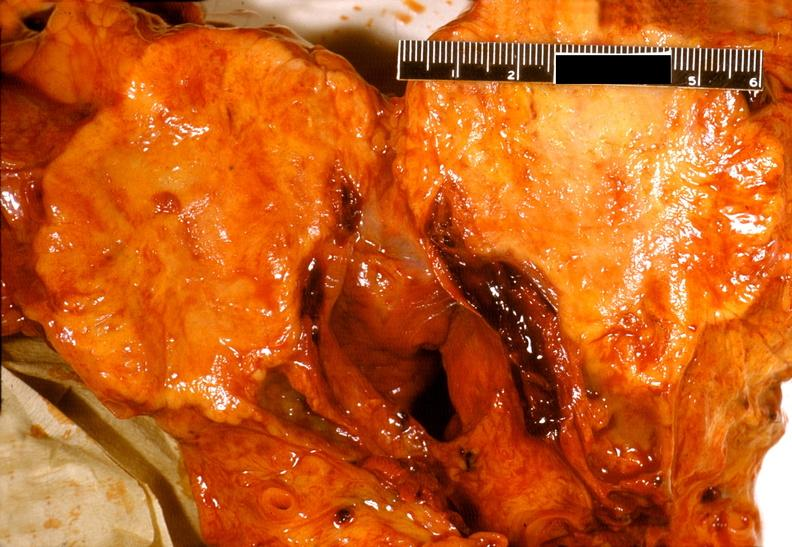does this image show adenocarcinoma, body of pancreas?
Answer the question using a single word or phrase. Yes 